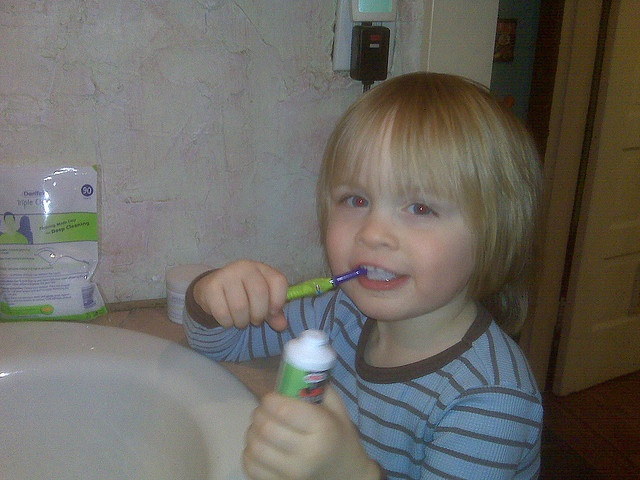Describe the objects in this image and their specific colors. I can see people in gray and black tones, people in gray tones, sink in gray tones, and toothbrush in gray, olive, and darkgreen tones in this image. 